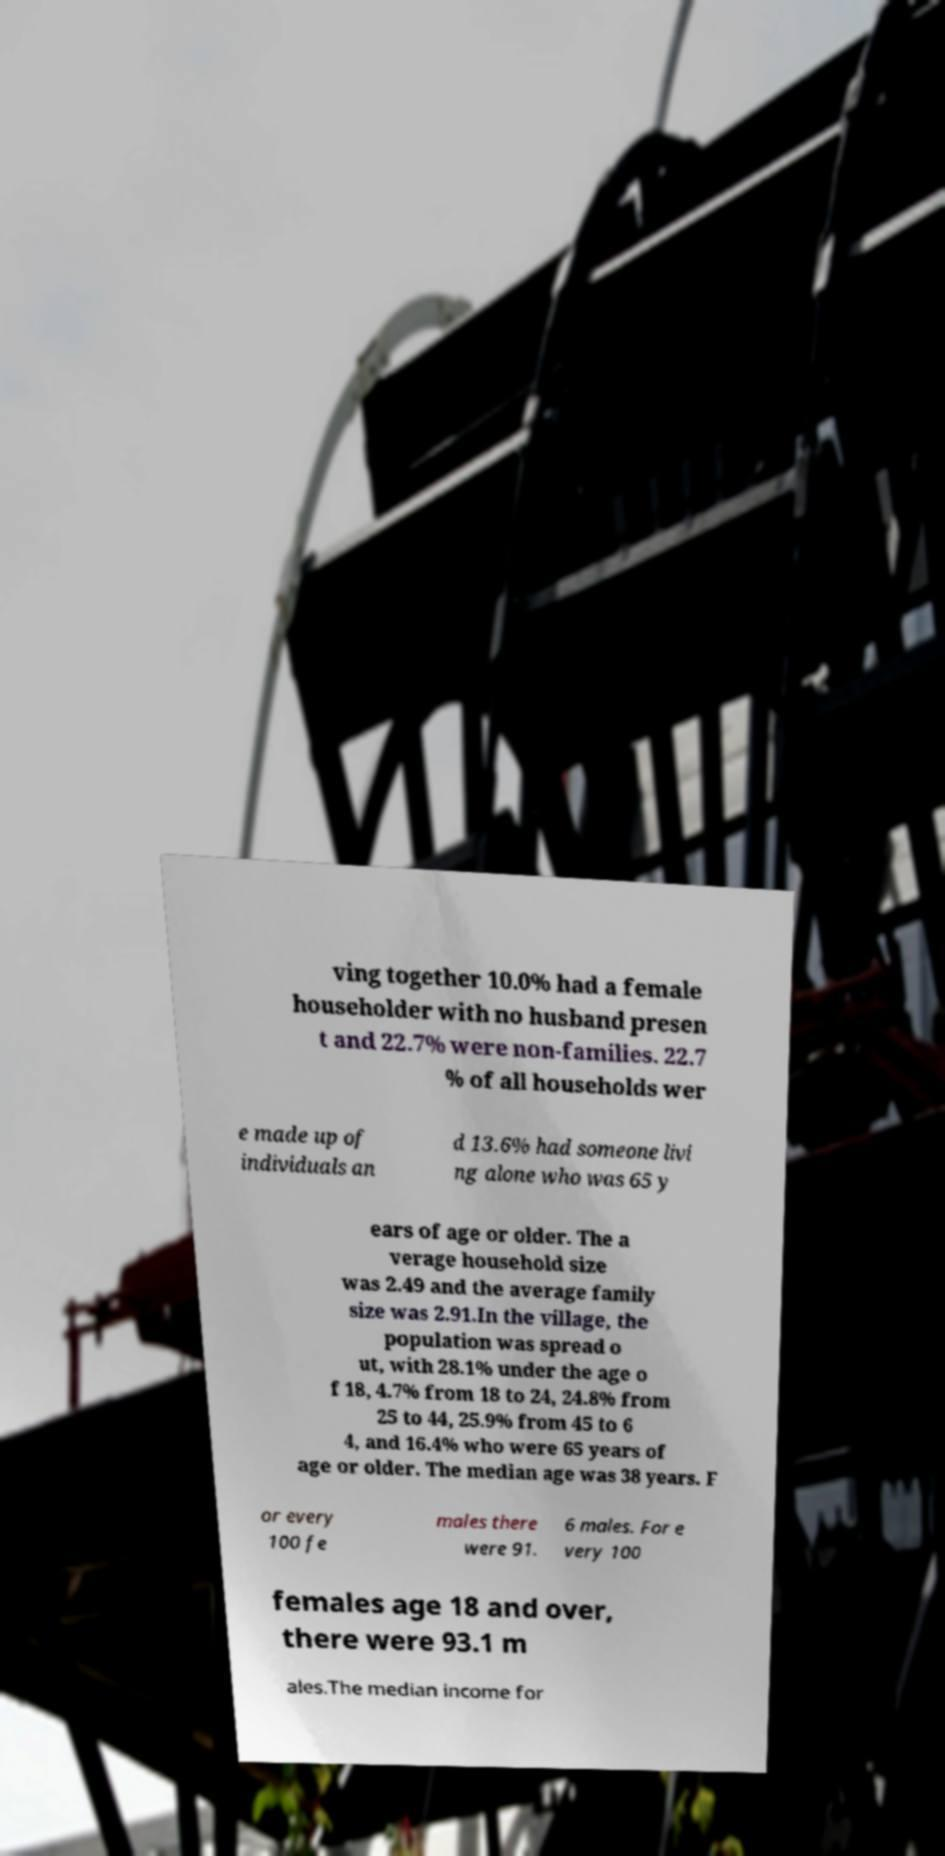Could you assist in decoding the text presented in this image and type it out clearly? ving together 10.0% had a female householder with no husband presen t and 22.7% were non-families. 22.7 % of all households wer e made up of individuals an d 13.6% had someone livi ng alone who was 65 y ears of age or older. The a verage household size was 2.49 and the average family size was 2.91.In the village, the population was spread o ut, with 28.1% under the age o f 18, 4.7% from 18 to 24, 24.8% from 25 to 44, 25.9% from 45 to 6 4, and 16.4% who were 65 years of age or older. The median age was 38 years. F or every 100 fe males there were 91. 6 males. For e very 100 females age 18 and over, there were 93.1 m ales.The median income for 